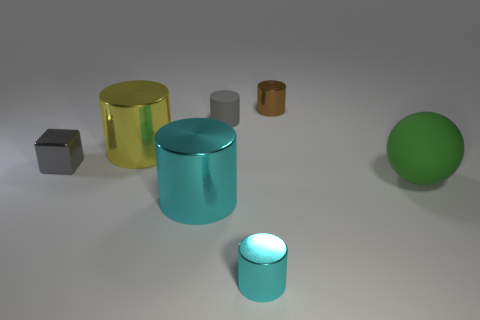There is a gray object that is to the right of the gray shiny thing; how big is it?
Offer a very short reply. Small. There is a rubber thing to the left of the tiny metal cylinder behind the large thing that is behind the large matte thing; what is its size?
Your answer should be compact. Small. Is the gray cylinder the same size as the yellow shiny cylinder?
Offer a very short reply. No. Are any tiny green metallic things visible?
Provide a short and direct response. No. How many cyan cylinders have the same size as the gray shiny thing?
Provide a short and direct response. 1. What number of small metal things are both behind the tiny cube and to the left of the big cyan shiny thing?
Ensure brevity in your answer.  0. Is the size of the matte thing behind the green rubber thing the same as the big yellow object?
Your answer should be very brief. No. Are there any other things of the same color as the small rubber object?
Your answer should be compact. Yes. There is a cylinder that is the same material as the green thing; what is its size?
Your answer should be very brief. Small. Is the number of gray things in front of the brown cylinder greater than the number of big cyan metal things that are right of the green rubber thing?
Give a very brief answer. Yes. 